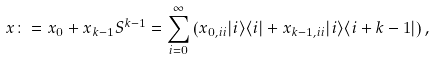Convert formula to latex. <formula><loc_0><loc_0><loc_500><loc_500>x \colon = x _ { 0 } + x _ { k - 1 } S ^ { k - 1 } = \sum _ { i = 0 } ^ { \infty } \left ( x _ { 0 , i i } | i \rangle \langle i | + x _ { k - 1 , i i } | i \rangle \langle i + k - 1 | \right ) ,</formula> 